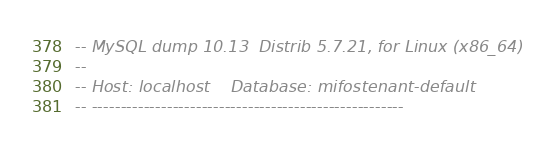<code> <loc_0><loc_0><loc_500><loc_500><_SQL_>-- MySQL dump 10.13  Distrib 5.7.21, for Linux (x86_64)
--
-- Host: localhost    Database: mifostenant-default
-- ------------------------------------------------------</code> 